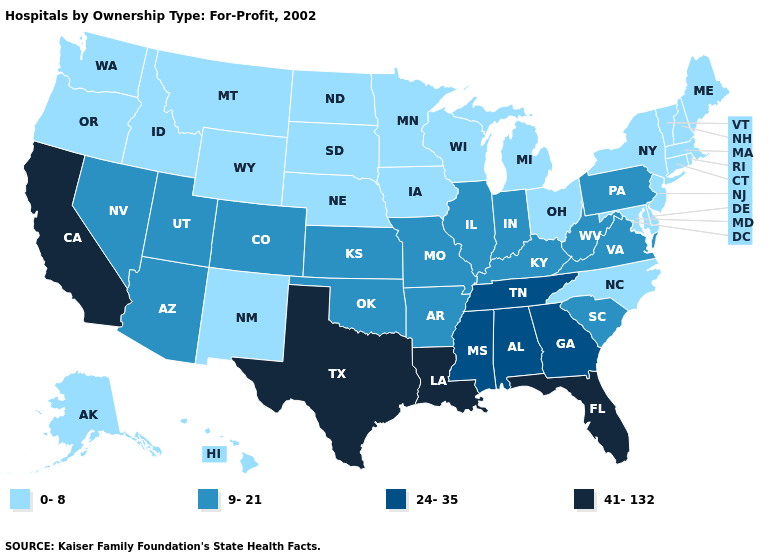Name the states that have a value in the range 9-21?
Give a very brief answer. Arizona, Arkansas, Colorado, Illinois, Indiana, Kansas, Kentucky, Missouri, Nevada, Oklahoma, Pennsylvania, South Carolina, Utah, Virginia, West Virginia. Does South Carolina have the lowest value in the South?
Write a very short answer. No. Does the first symbol in the legend represent the smallest category?
Quick response, please. Yes. Which states have the lowest value in the USA?
Be succinct. Alaska, Connecticut, Delaware, Hawaii, Idaho, Iowa, Maine, Maryland, Massachusetts, Michigan, Minnesota, Montana, Nebraska, New Hampshire, New Jersey, New Mexico, New York, North Carolina, North Dakota, Ohio, Oregon, Rhode Island, South Dakota, Vermont, Washington, Wisconsin, Wyoming. What is the value of Maine?
Write a very short answer. 0-8. Does Oregon have a lower value than Oklahoma?
Short answer required. Yes. Does Rhode Island have the same value as Delaware?
Be succinct. Yes. Name the states that have a value in the range 24-35?
Quick response, please. Alabama, Georgia, Mississippi, Tennessee. What is the highest value in the USA?
Keep it brief. 41-132. Among the states that border West Virginia , which have the highest value?
Concise answer only. Kentucky, Pennsylvania, Virginia. What is the lowest value in states that border California?
Write a very short answer. 0-8. Name the states that have a value in the range 0-8?
Write a very short answer. Alaska, Connecticut, Delaware, Hawaii, Idaho, Iowa, Maine, Maryland, Massachusetts, Michigan, Minnesota, Montana, Nebraska, New Hampshire, New Jersey, New Mexico, New York, North Carolina, North Dakota, Ohio, Oregon, Rhode Island, South Dakota, Vermont, Washington, Wisconsin, Wyoming. Among the states that border South Carolina , which have the highest value?
Short answer required. Georgia. Which states hav the highest value in the West?
Write a very short answer. California. Name the states that have a value in the range 0-8?
Keep it brief. Alaska, Connecticut, Delaware, Hawaii, Idaho, Iowa, Maine, Maryland, Massachusetts, Michigan, Minnesota, Montana, Nebraska, New Hampshire, New Jersey, New Mexico, New York, North Carolina, North Dakota, Ohio, Oregon, Rhode Island, South Dakota, Vermont, Washington, Wisconsin, Wyoming. 